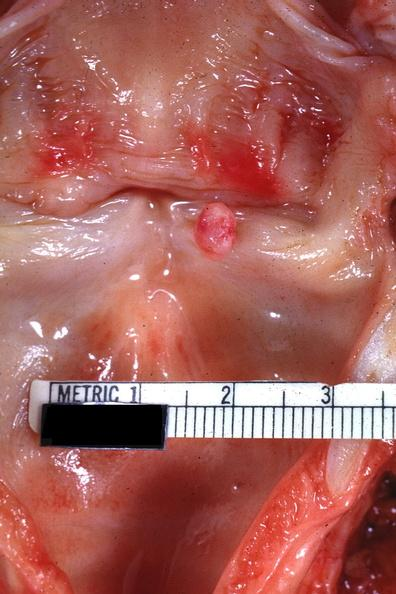what is present?
Answer the question using a single word or phrase. Papilloma on vocal cord 